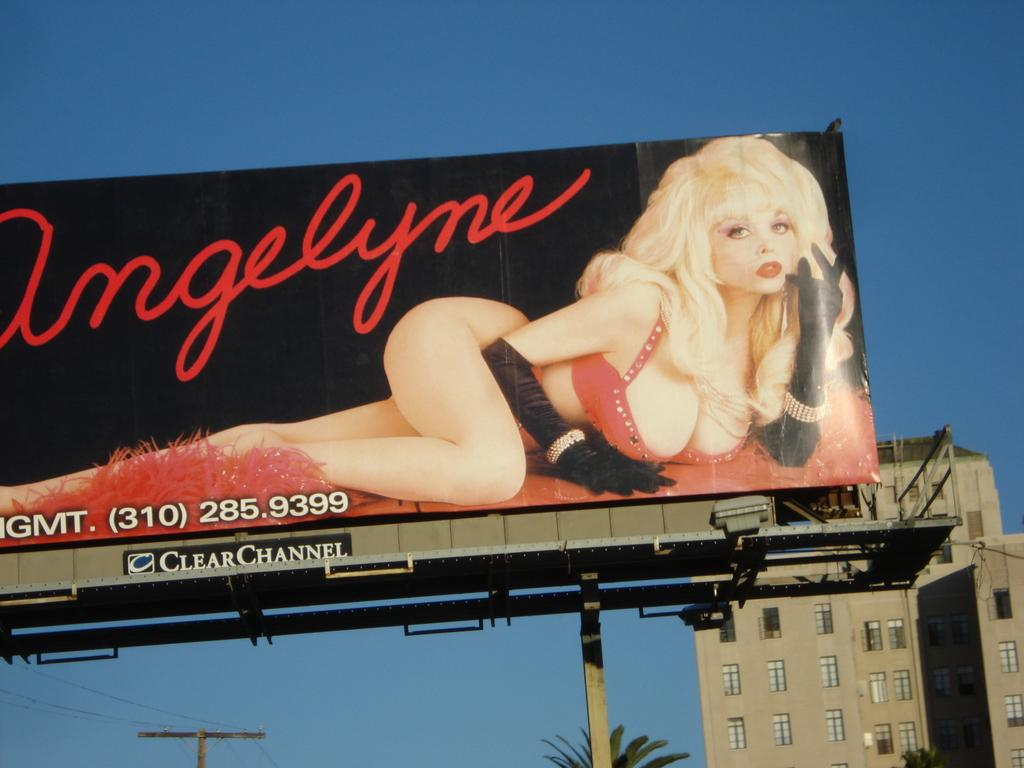Provide a one-sentence caption for the provided image. the word angelyne that is on a billboard. 